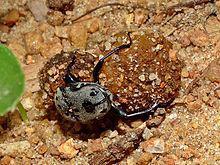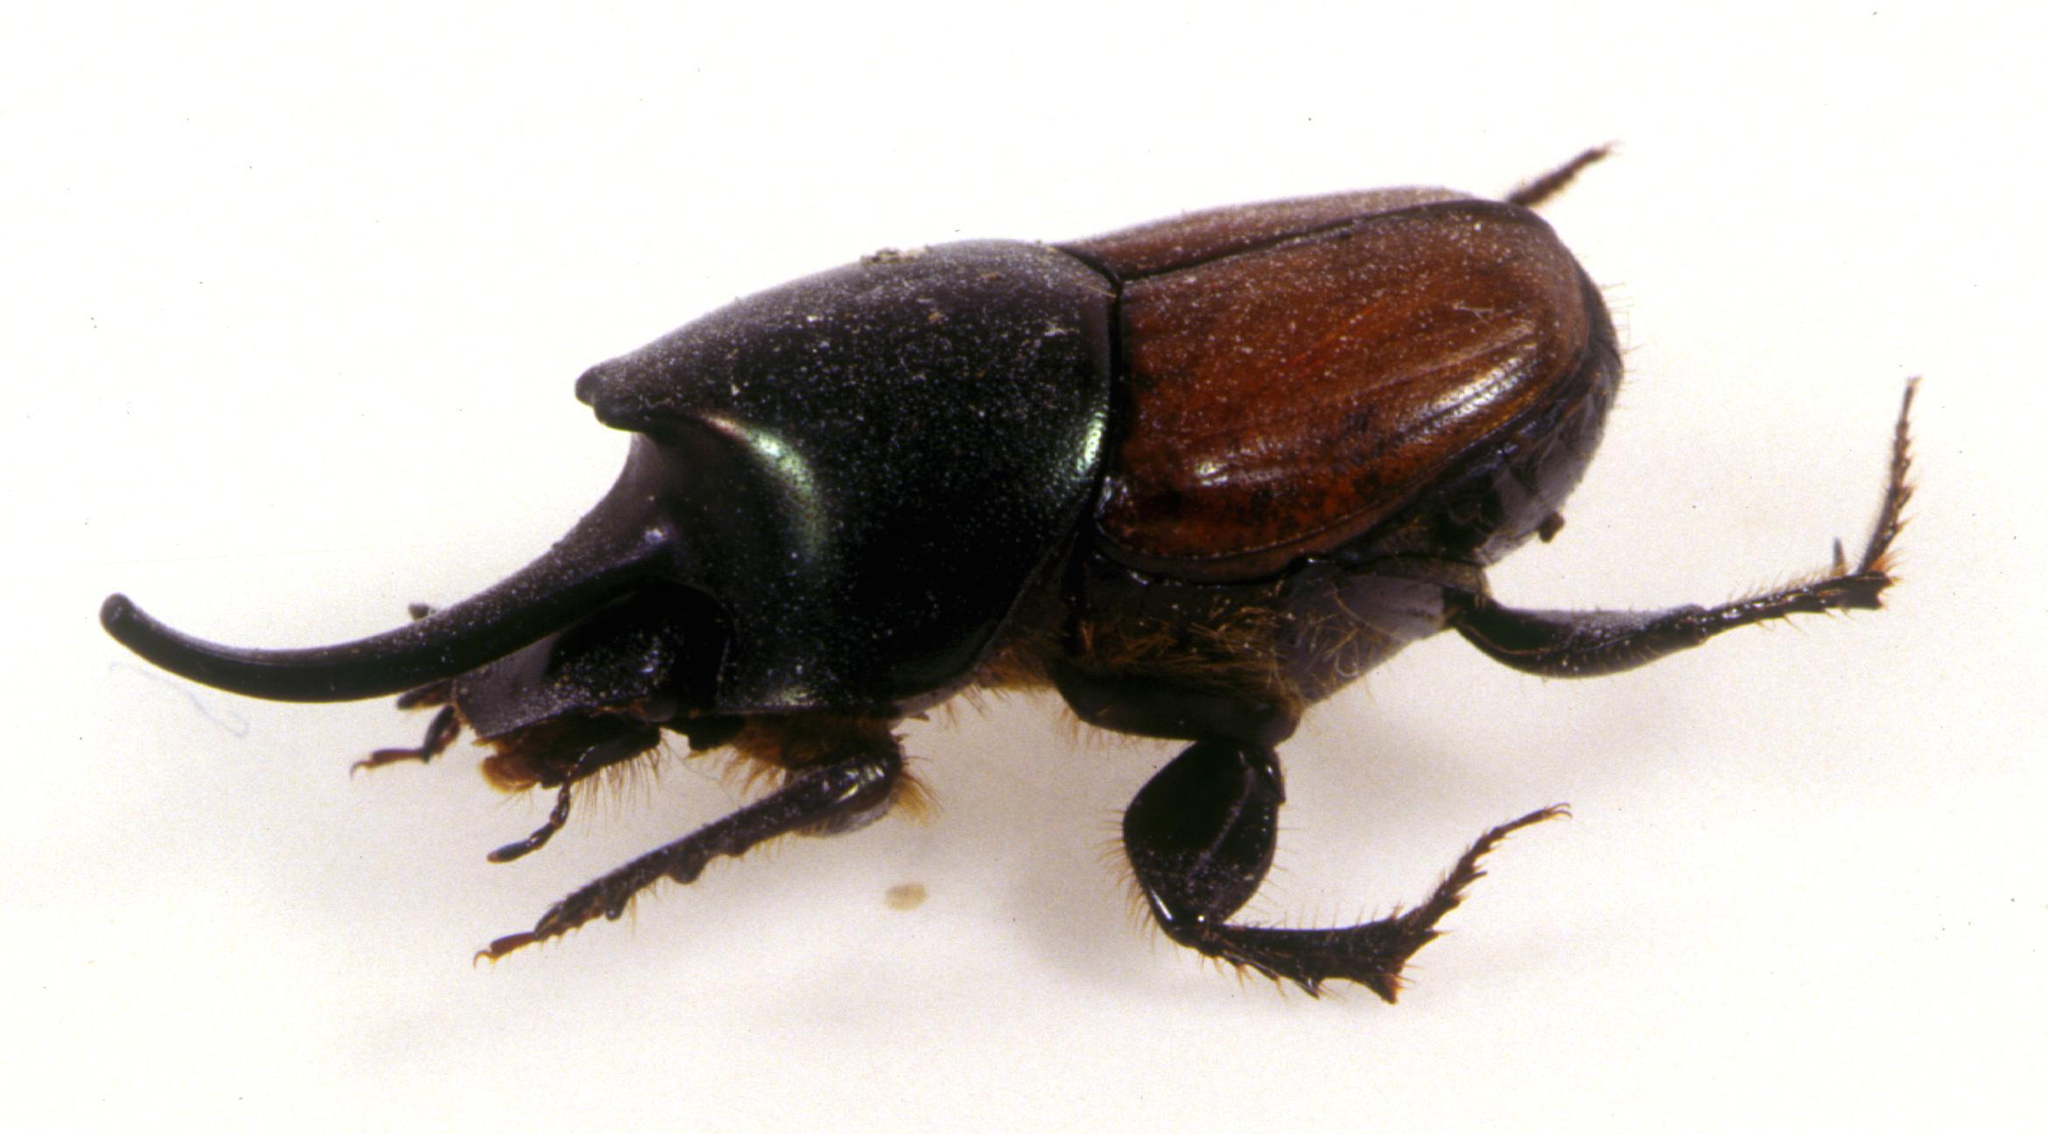The first image is the image on the left, the second image is the image on the right. Assess this claim about the two images: "Each image features a beetle in contact with a dung ball.". Correct or not? Answer yes or no. No. The first image is the image on the left, the second image is the image on the right. Assess this claim about the two images: "Only one beetle is on a ball of dirt.". Correct or not? Answer yes or no. Yes. 